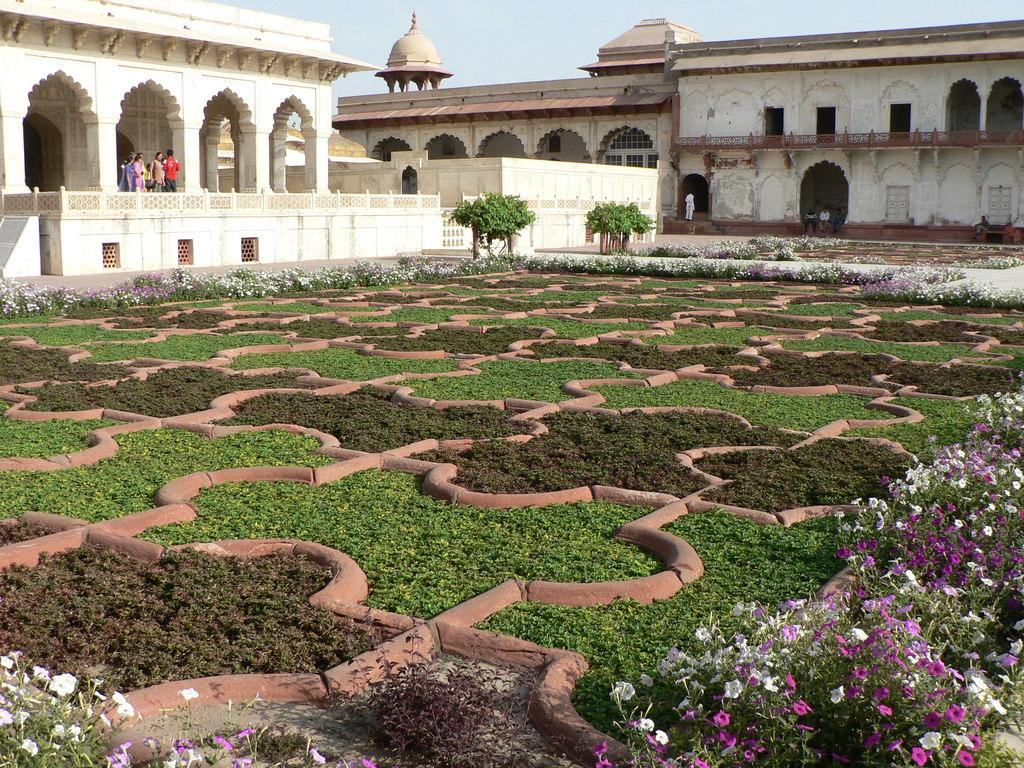What type of vegetation can be seen in the image? There is grass, plants with flowers, and trees in the image. Are there any living beings present in the image? Yes, there are people in the image. What structures can be seen in the image? There are buildings in the image. What part of the natural environment is visible in the image? The sky is visible in the background of the image. What type of oatmeal is being served to the daughter in the image? There is no daughter or oatmeal present in the image. What type of print can be seen on the buildings in the image? The provided facts do not mention any specific prints on the buildings in the image. 